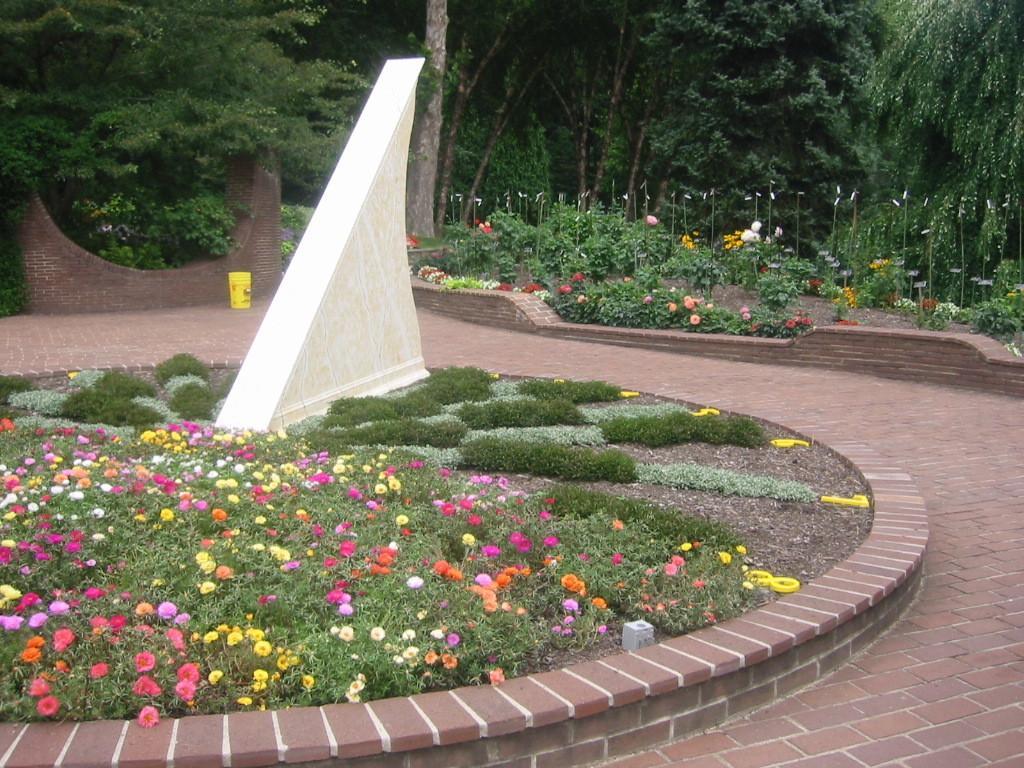Please provide a concise description of this image. In this picture we can see plants with flowers, grass, wall and some objects on the ground and in the background we can see trees. 